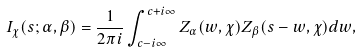Convert formula to latex. <formula><loc_0><loc_0><loc_500><loc_500>I _ { \chi } ( s ; \alpha , \beta ) = \frac { 1 } { 2 \pi i } \int _ { c - i \infty } ^ { c + i \infty } Z _ { \alpha } ( w , \chi ) Z _ { \beta } ( s - w , \chi ) d w ,</formula> 